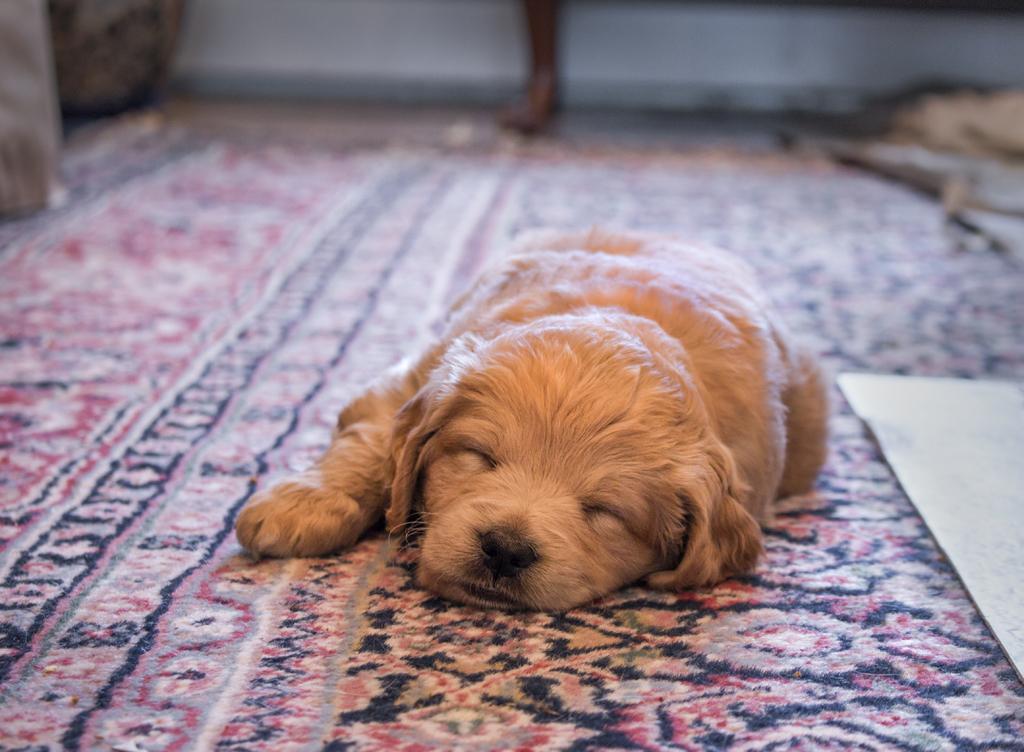Describe this image in one or two sentences. In the center of this picture we can see a dog sleeping on the floor mat. In the background we can see some other objects and we can see the wall. 